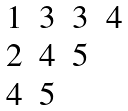Convert formula to latex. <formula><loc_0><loc_0><loc_500><loc_500>\begin{matrix} 1 & 3 & 3 & 4 \\ 2 & 4 & 5 & \\ 4 & 5 & & \end{matrix}</formula> 